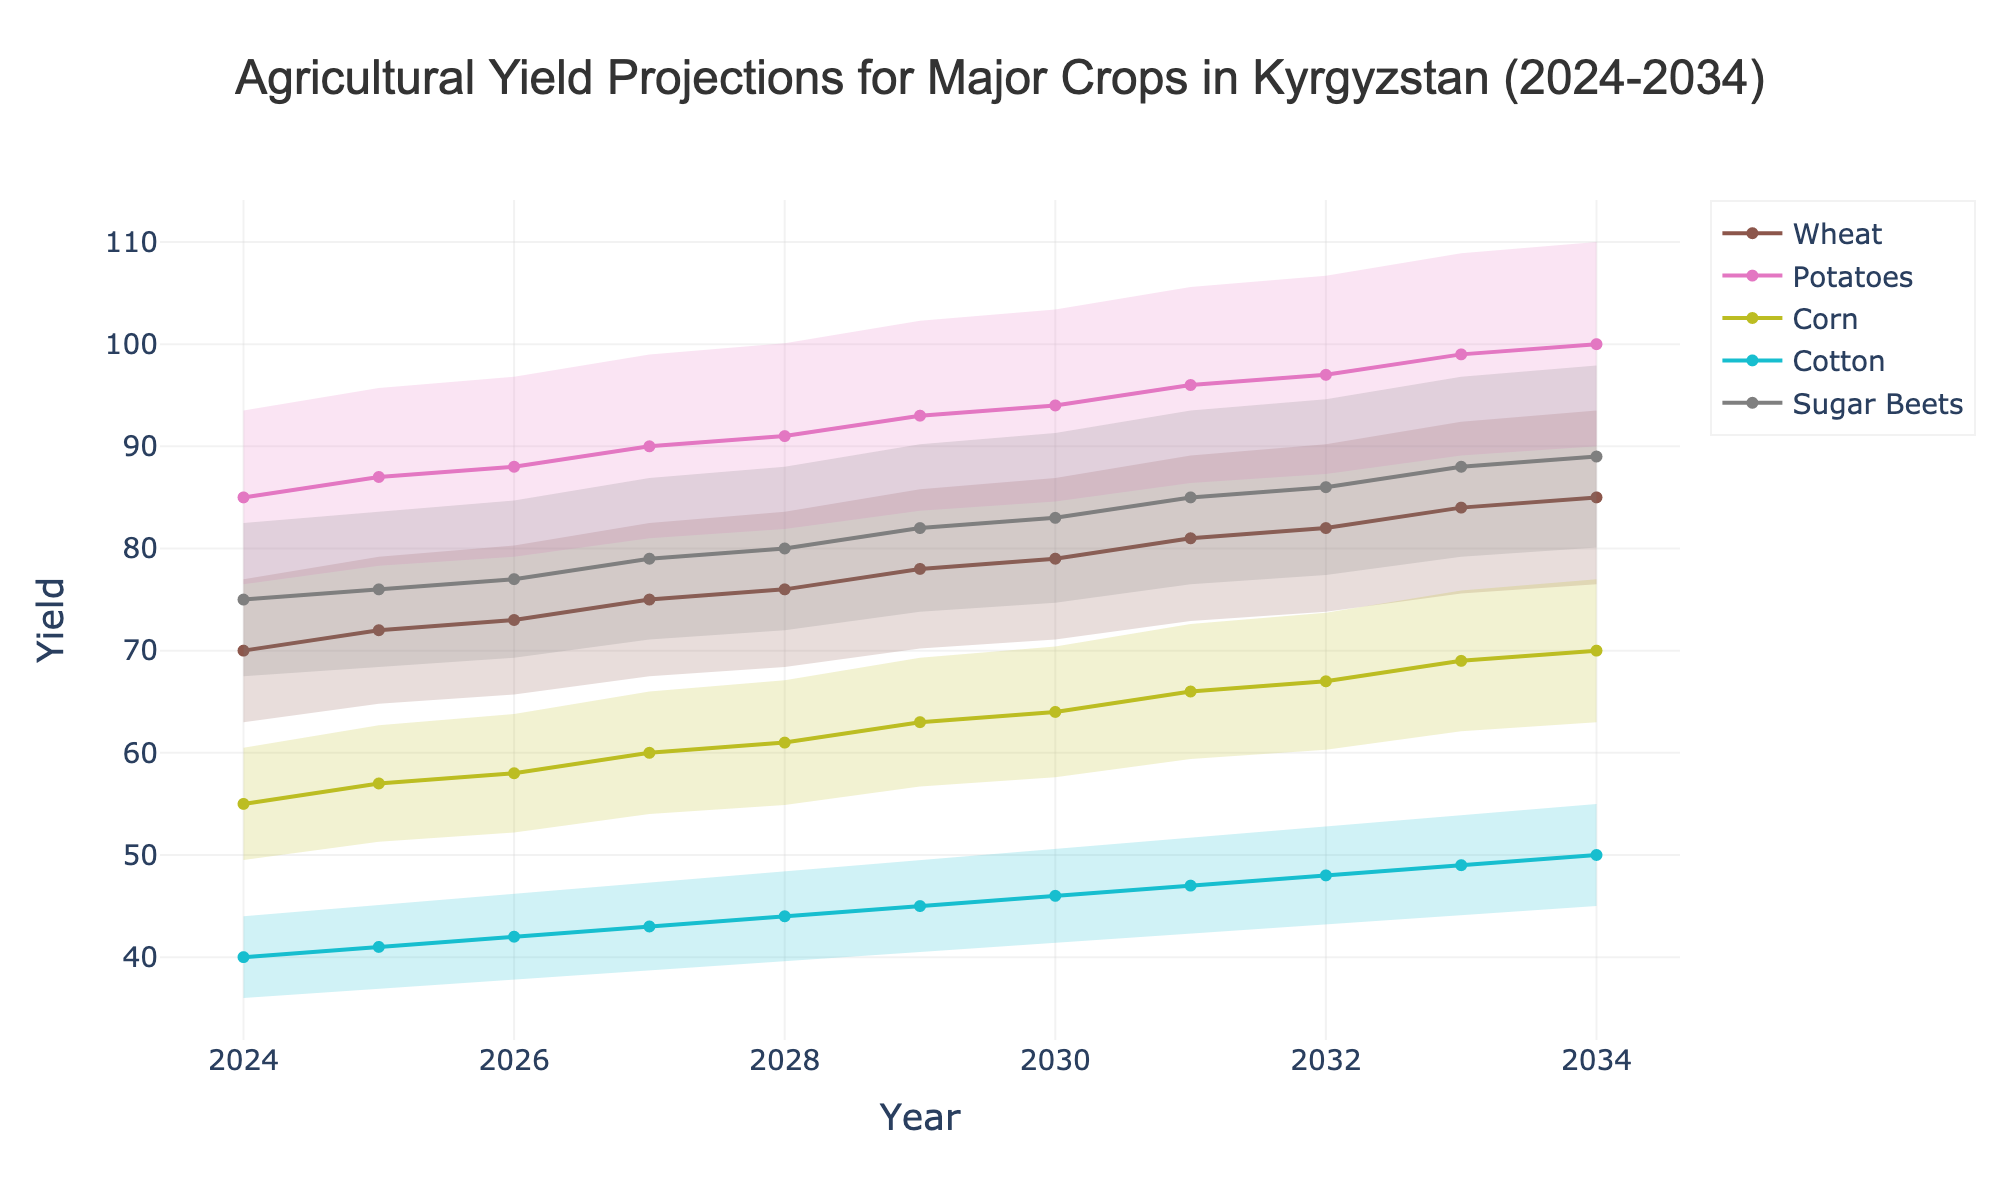What is the title of the chart? The title is usually placed at the top of a chart and provides a brief description of the content. In this chart, the title is visible at the top center.
Answer: Agricultural Yield Projections for Major Crops in Kyrgyzstan (2024-2034) What does the x-axis represent in this chart? The x-axis often represents the timeline or progression in charts. In this case, it denotes the years from 2024 to 2034.
Answer: Year Which crop has the highest projection in 2034? By looking at the end of each crop’s projection line for the year 2034, the comparison shows which has the highest value.
Answer: Potatoes How many years of projections are shown in the chart? The projections start from 2024 and end in 2034. Counting the years between these two points, including both end years, gives the total number.
Answer: 11 What is the projected yield for Wheat in 2028? Locating the point on Wheat's trend line that corresponds to the year 2028 will provide the yield value.
Answer: 76 Which crop shows the largest increase from 2024 to 2034? Calculate the difference between the projected yield values for each crop between 2024 and 2034, then identify the largest difference.
Answer: Potatoes What is the approximate range of yield for Corn in the year 2026? The fan chart will display an upper and a lower bound for Corn's yield in 2026, which sets the range.
Answer: 52.2 to 63.8 How do the projections for Sugar Beets in 2029 compare to Wheat for the same year? Find the values for Sugar Beets and Wheat in 2029 and then compare them.
Answer: Sugar Beets have a higher projection What is the average projected yield for Cotton over the decade? Sum up the projected yields for Cotton across all years from 2024 to 2034 and then divide by the number of years (11).
Answer: 45 How does the uncertainty range for Potatoes in 2033 compare to that in 2025? Identify the upper and lower bounds for Potatoes in both years and compare the width of the uncertainty ranges.
Answer: The uncertainty range widens from 2025 to 2033 